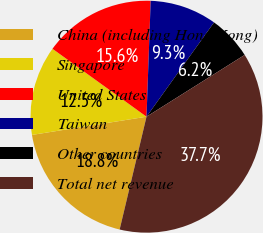<chart> <loc_0><loc_0><loc_500><loc_500><pie_chart><fcel>China (including Hong Kong)<fcel>Singapore<fcel>United States<fcel>Taiwan<fcel>Other countries<fcel>Total net revenue<nl><fcel>18.77%<fcel>12.47%<fcel>15.62%<fcel>9.32%<fcel>6.17%<fcel>37.67%<nl></chart> 